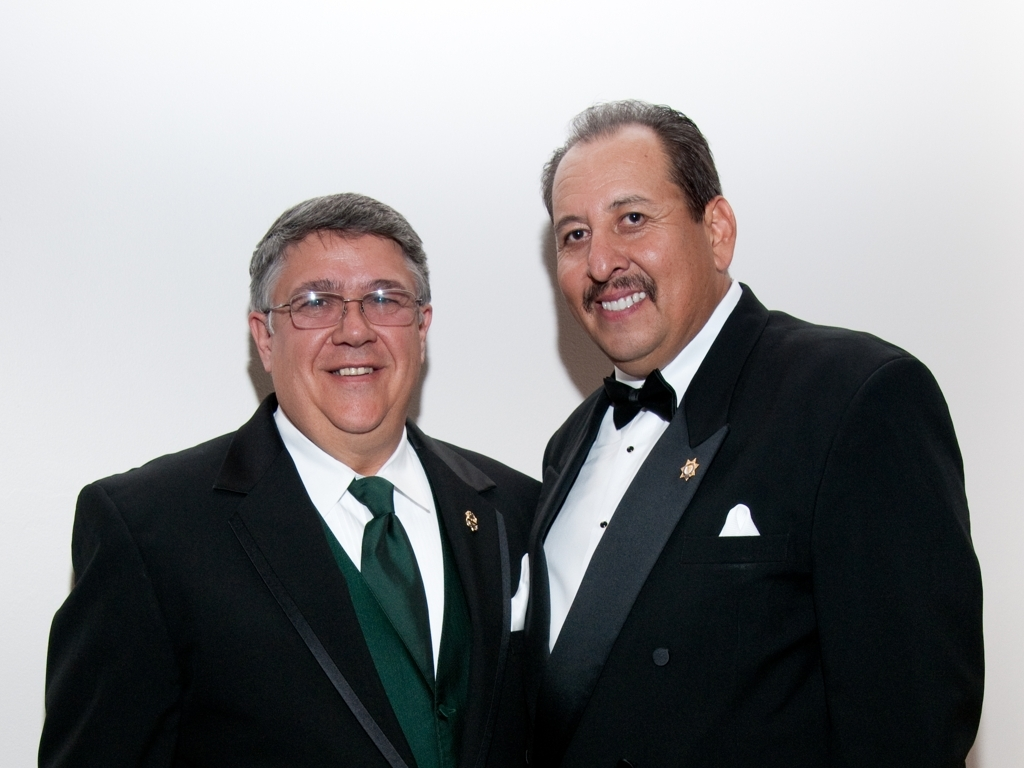What emotions do the individuals appear to be expressing in this image? Both individuals have warm smiles and appear to be happy and content. Their eyes are slightly creased, which often signifies genuine smiles, and the overall impression is that they are enjoying the moment and each other's company, possibly celebrating a happy occasion. 